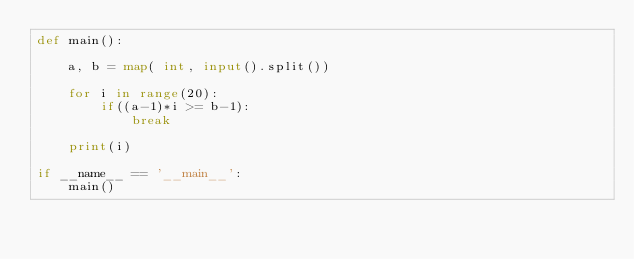<code> <loc_0><loc_0><loc_500><loc_500><_Python_>def main():

    a, b = map( int, input().split())

    for i in range(20):
        if((a-1)*i >= b-1):
            break
    
    print(i)

if __name__ == '__main__':
    main()

</code> 